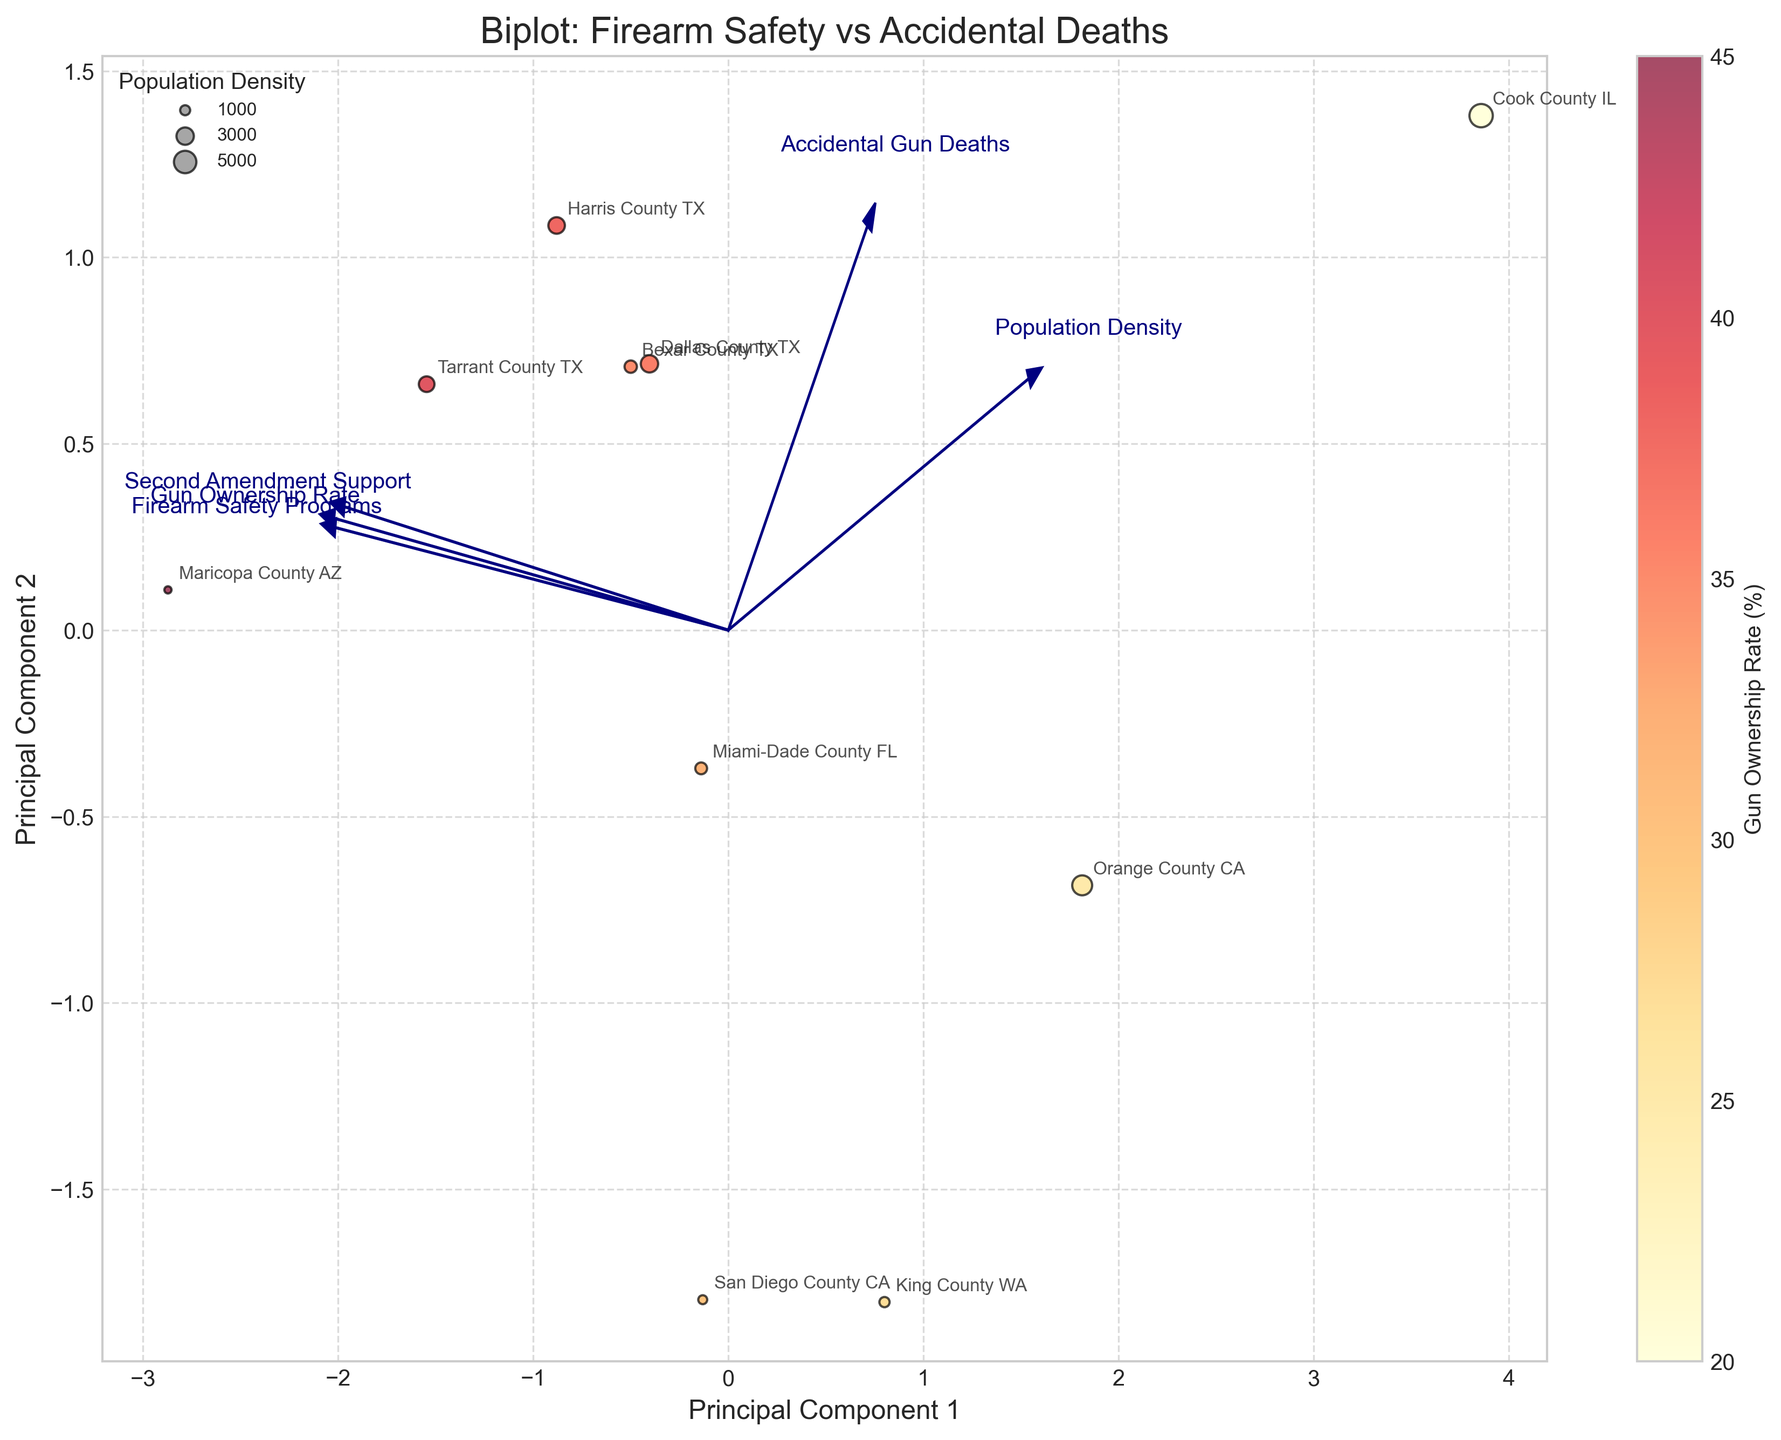what is the title of the plot? The title of the plot is shown at the top of the figure. It provides a description of what the plot represents.
Answer: Biplot: Firearm Safety vs Accidental Deaths How many data points are displayed in the plot? Each county represents a data point. Count the number of counties listed in the data points.
Answer: 10 Which county has the highest population density? The county with the largest circle size represents the highest population density. Look for the largest circle in the plot.
Answer: Cook County IL For which variable is the vector pointing mostly to the right? The variable with the vector pointing mostly to the right would have a high positive value on the Principal Component 1 axis (x-axis). Identify which arrow mostly points to the right.
Answer: Second Amendment Support Do more firearm safety programs correlate with lower accidental gun deaths based on the vectors' directions? Compare the direction of the 'Firearm Safety Programs' and 'Accidental Gun Deaths' vectors. If they point in opposite directions, they are negatively correlated.
Answer: Yes, they are negatively correlated Which variable seems most influential on Principal Component 1? The variable with the longest vector projection onto the Principal Component 1 axis (x-axis) is most influential. Identify which vector has the highest magnitude in the x-direction.
Answer: Second Amendment Support Which variables have a stronger relationship based on the angle between their vectors? Variables with vectors pointing in the same or opposite direction (small angle between them) have a stronger relationship. Identify which pairs of vectors have the smallest angles.
Answer: Gun Ownership Rate and Second Amendment Support Does Cook County, IL, have higher accidental gun deaths than King County, WA? Locate the positions for Cook County, IL, and King County, WA, and compare their values along the Principal Component 2 axis (y-axis for gun deaths). The county higher on the y-axis has more accidental gun deaths.
Answer: Yes 